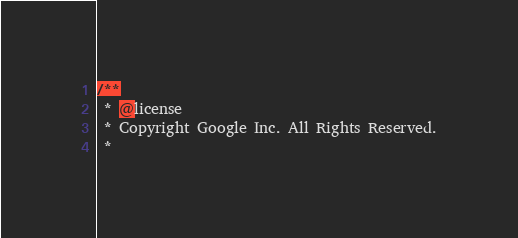Convert code to text. <code><loc_0><loc_0><loc_500><loc_500><_JavaScript_>/**
 * @license
 * Copyright Google Inc. All Rights Reserved.
 *</code> 